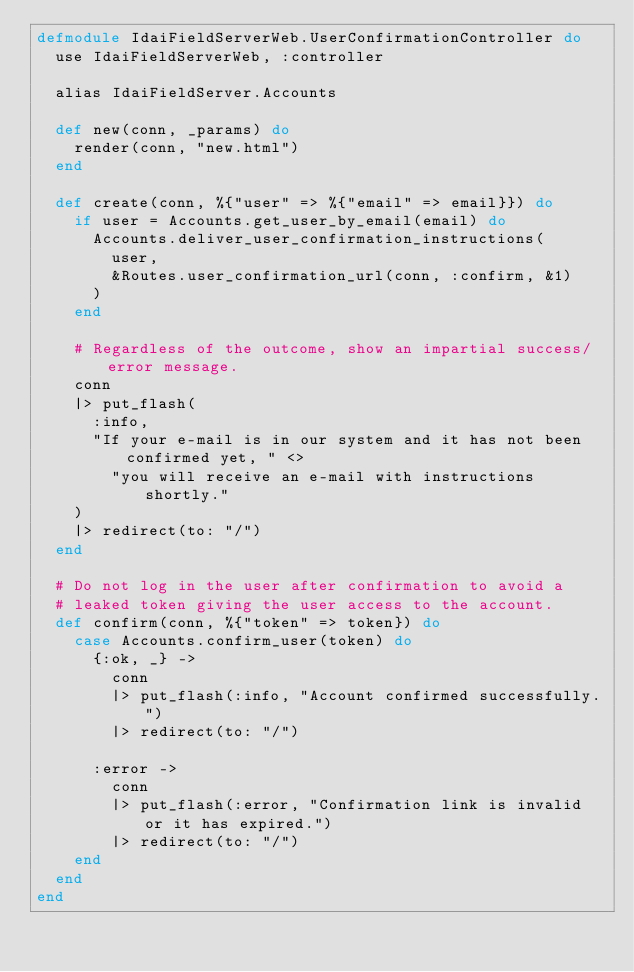Convert code to text. <code><loc_0><loc_0><loc_500><loc_500><_Elixir_>defmodule IdaiFieldServerWeb.UserConfirmationController do
  use IdaiFieldServerWeb, :controller

  alias IdaiFieldServer.Accounts

  def new(conn, _params) do
    render(conn, "new.html")
  end

  def create(conn, %{"user" => %{"email" => email}}) do
    if user = Accounts.get_user_by_email(email) do
      Accounts.deliver_user_confirmation_instructions(
        user,
        &Routes.user_confirmation_url(conn, :confirm, &1)
      )
    end

    # Regardless of the outcome, show an impartial success/error message.
    conn
    |> put_flash(
      :info,
      "If your e-mail is in our system and it has not been confirmed yet, " <>
        "you will receive an e-mail with instructions shortly."
    )
    |> redirect(to: "/")
  end

  # Do not log in the user after confirmation to avoid a
  # leaked token giving the user access to the account.
  def confirm(conn, %{"token" => token}) do
    case Accounts.confirm_user(token) do
      {:ok, _} ->
        conn
        |> put_flash(:info, "Account confirmed successfully.")
        |> redirect(to: "/")

      :error ->
        conn
        |> put_flash(:error, "Confirmation link is invalid or it has expired.")
        |> redirect(to: "/")
    end
  end
end
</code> 